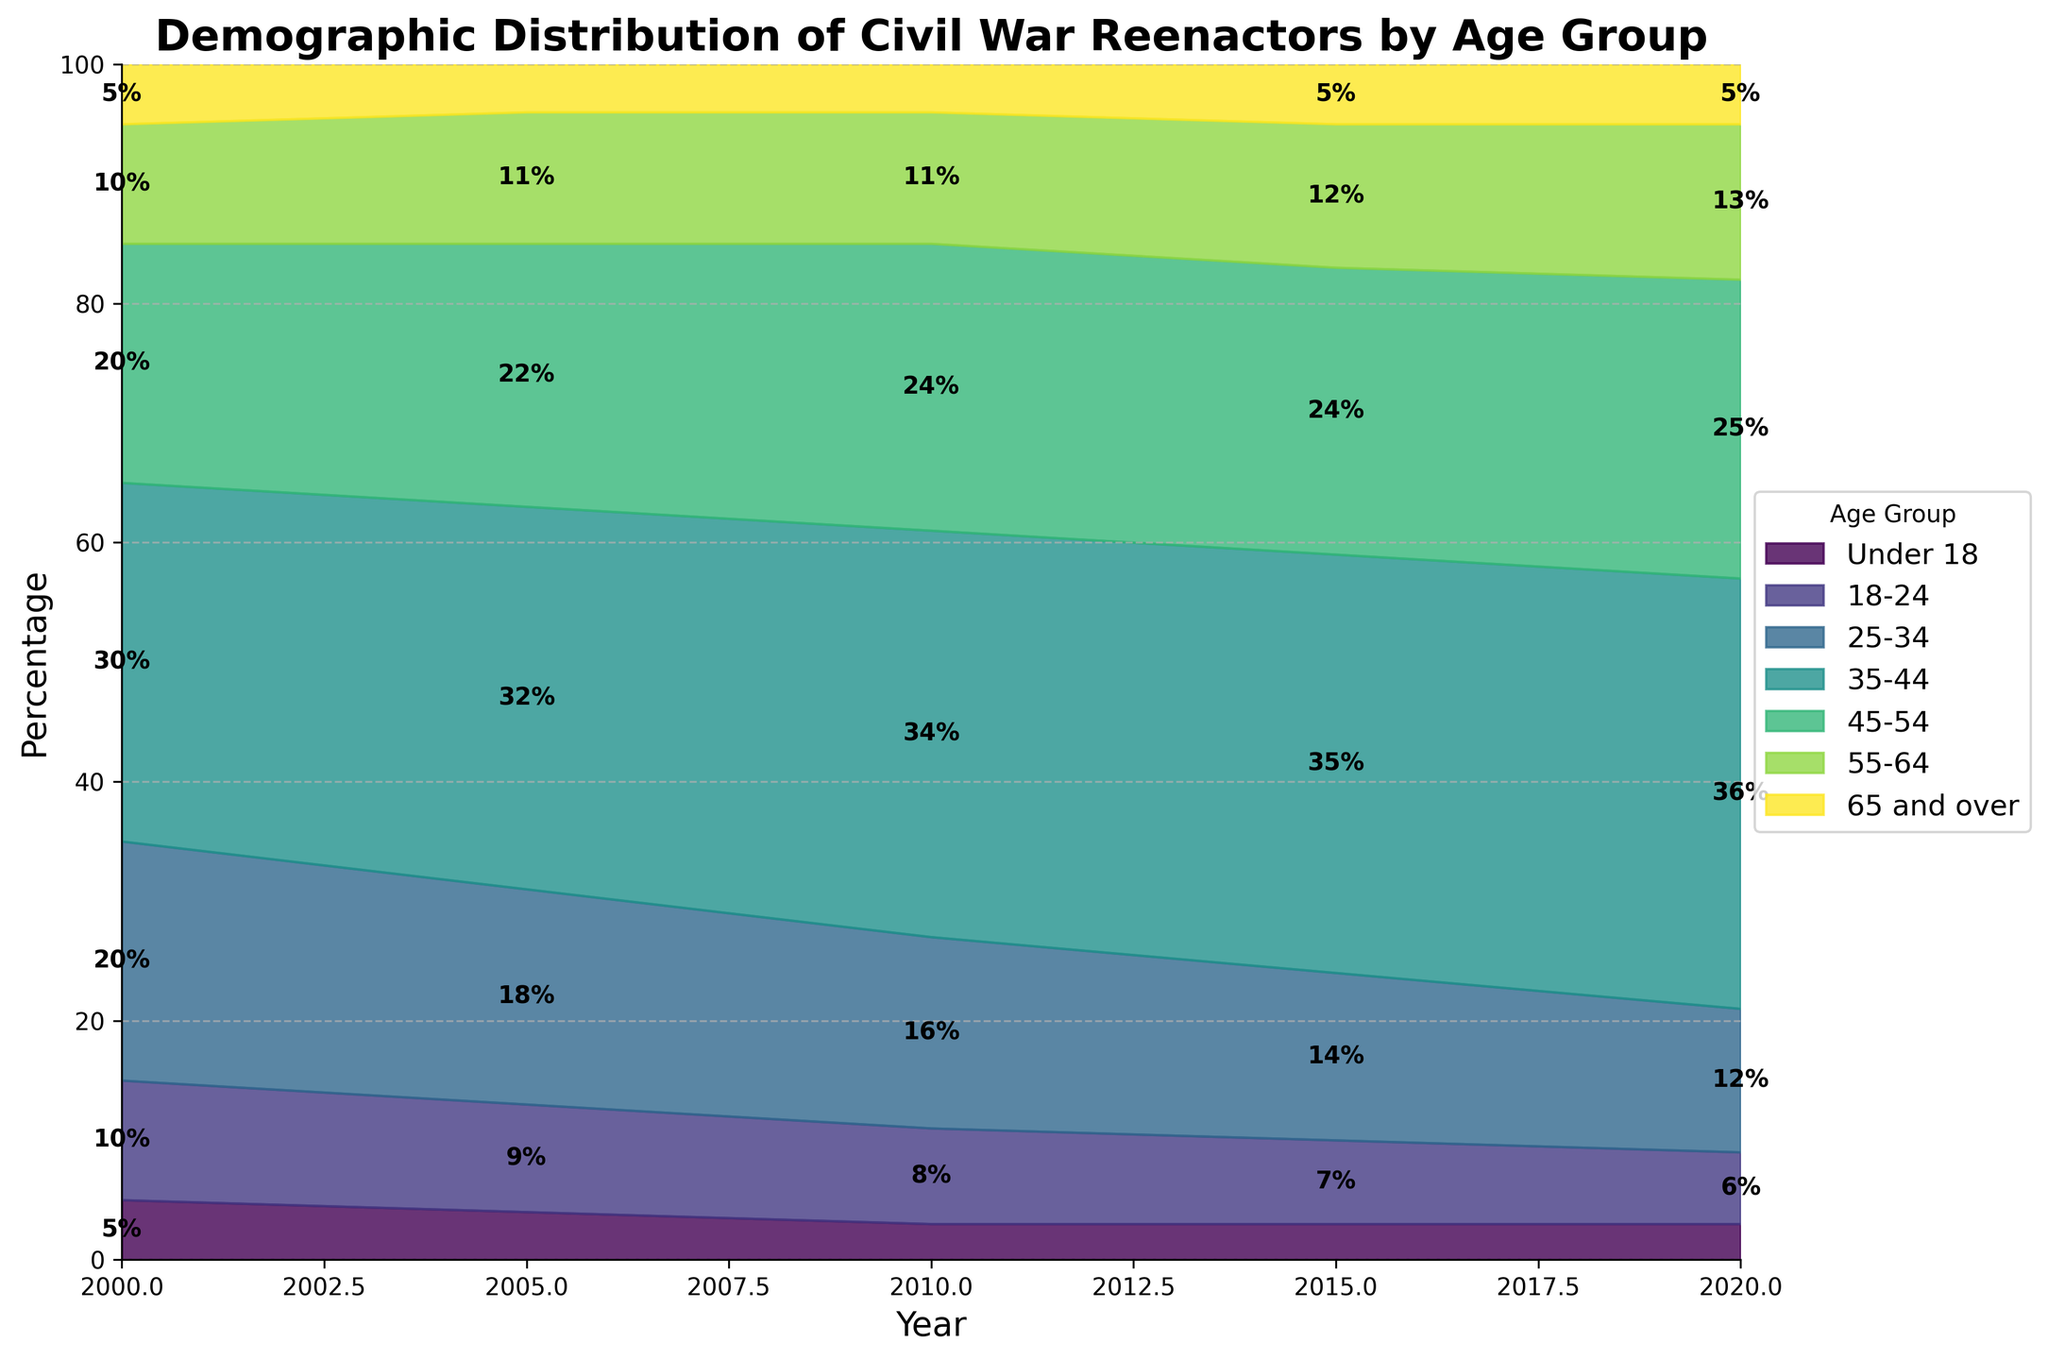What is the title of the chart? The title of the chart is found at the top of the figure, making it straightforward to identify.
Answer: Demographic Distribution of Civil War Reenactors by Age Group How does the percentage of reenactors aged 35-44 change from 2000 to 2020? In 2000, the percentage of reenactors aged 35-44 is 30%. By 2020, this percentage increases to 36%. To see the change, subtract the earlier value from the later one: 36% - 30% = 6%.
Answer: Increases by 6% Which age group consistently has the lowest percentage of participants across all years? By inspecting the bottom most sections of each stacked area for the lowest values, the "65 and over" group consistently has the smallest percentage across every year shown.
Answer: 65 and over Which age group had the highest percentage of participants in 2020? By examining the topmost layers of the stacked area in 2020, the "35-44" age group is the most extensive section, indicating the highest percentage at 36%.
Answer: 35-44 Between which two consecutive years was the percentage of the 25-34 age group the highest? By closely examining the layers for the 25-34 age group, it is evident that its highest percentage of participants occurs in the interval between 2000 and 2005, where it peaks at 20% and 18%.
Answer: 2000 and 2005 Which year shows a decrease in the percentage for the "18-24" age group, compared to its previous year? A visual comparison of each section for the 18-24 age group indicates a decrease in percentage from 9% in 2005 to 8% in 2010.
Answer: 2010 What trends do you observe in the age group "55-64" over the years? By analyzing the given sections for "55-64," it is clear that the percentage gradually increases from 10% in 2000 to 13% by 2020. Although it experiences small fluctuations, the overall trend is upward over the years.
Answer: Increasing How do the percentages of reenactors aged Under 18 change over the two decades? Starting at 5% in 2000, the percentage decreases to 4% in 2005, then to 3% in 2010, 2015, and finally remains stable at 3% in 2020.
Answer: Decreases and then stabilizes In what year did the age group "45-54" peak, and what was the percentage? Observing the stacked sections for each year, the age group "45-54" peaked in 2020, reaching a high of 25%.
Answer: 2020 at 25% What is the overall trend for participants aged "25-34" from 2000 to 2020? Initially, the percentage for the "25-34" age group drops from 20% in 2000 to 12% in 2020. This indicates a long-term decreasing trend over the given period.
Answer: Decreasing 